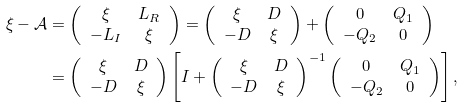<formula> <loc_0><loc_0><loc_500><loc_500>\xi - { \mathcal { A } } & = \left ( \begin{array} { c c } \xi & L _ { R } \\ - L _ { I } & \xi \end{array} \right ) = \left ( \begin{array} { c c } \xi & D \\ - D & \xi \end{array} \right ) + \left ( \begin{array} { c c } 0 & Q _ { 1 } \\ - Q _ { 2 } & 0 \end{array} \right ) \\ & = \left ( \begin{array} { c c } \xi & D \\ - D & \xi \end{array} \right ) \left [ I + \left ( \begin{array} { c c } \xi & D \\ - D & \xi \end{array} \right ) ^ { - 1 } \left ( \begin{array} { c c } 0 & Q _ { 1 } \\ - Q _ { 2 } & 0 \end{array} \right ) \right ] ,</formula> 